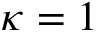Convert formula to latex. <formula><loc_0><loc_0><loc_500><loc_500>\kappa = 1</formula> 